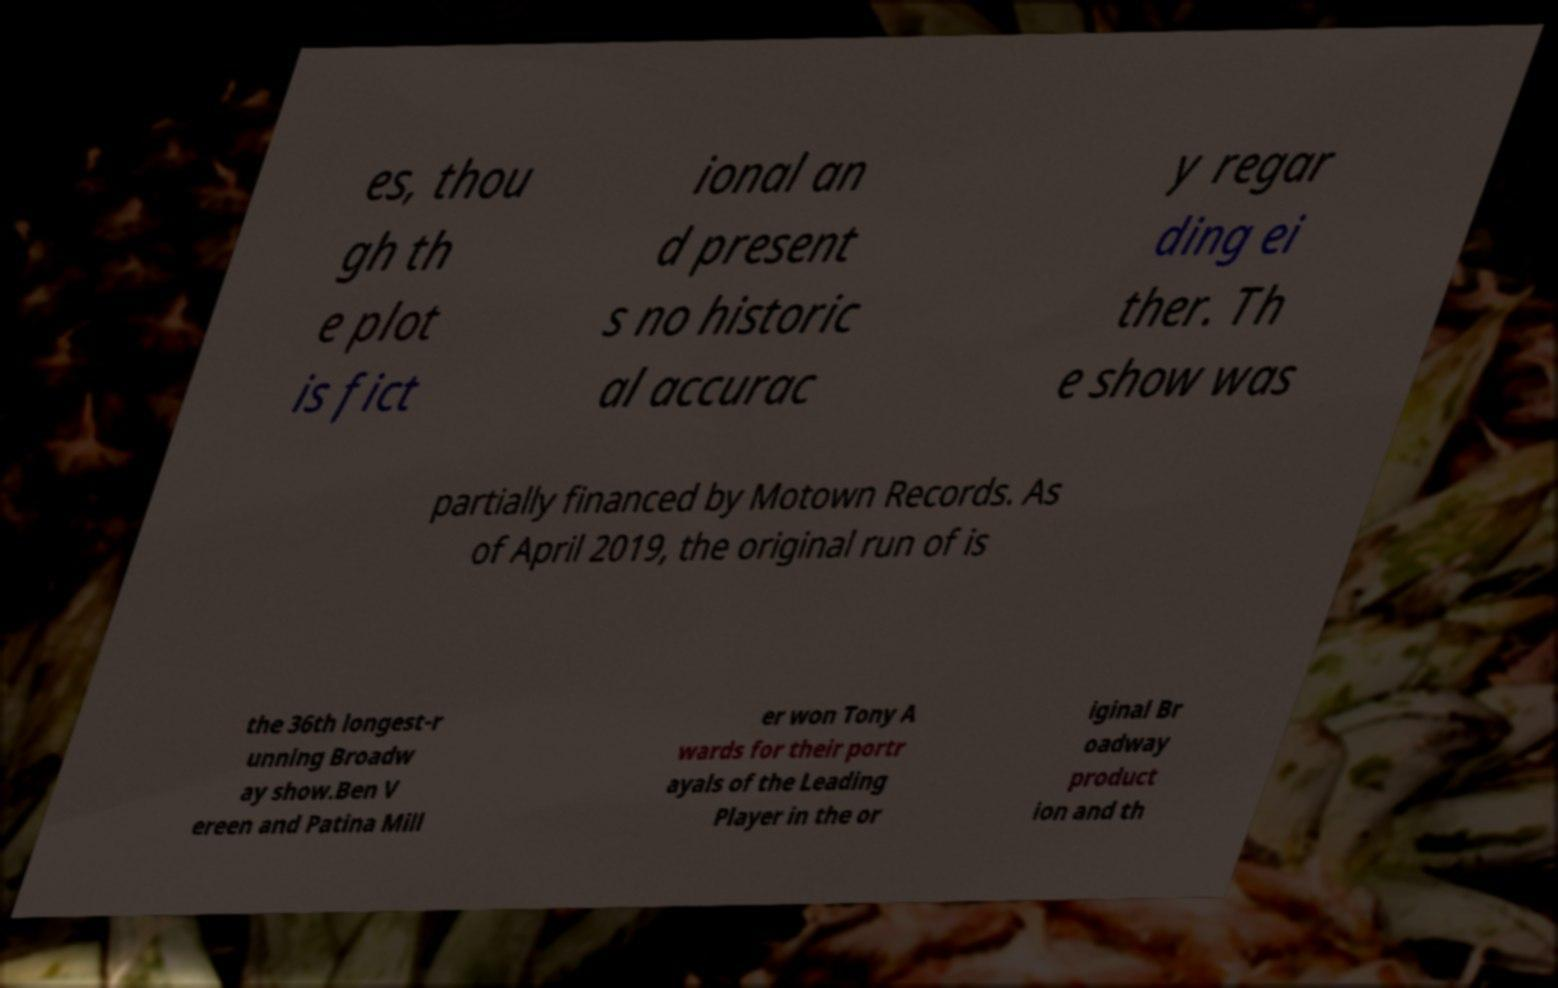Could you assist in decoding the text presented in this image and type it out clearly? es, thou gh th e plot is fict ional an d present s no historic al accurac y regar ding ei ther. Th e show was partially financed by Motown Records. As of April 2019, the original run of is the 36th longest-r unning Broadw ay show.Ben V ereen and Patina Mill er won Tony A wards for their portr ayals of the Leading Player in the or iginal Br oadway product ion and th 